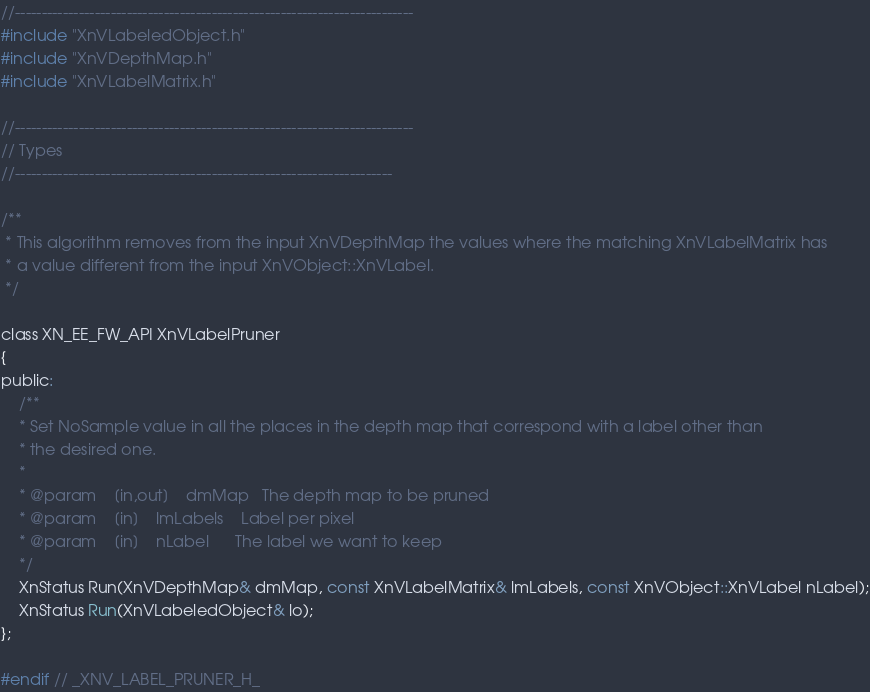Convert code to text. <code><loc_0><loc_0><loc_500><loc_500><_C_>//---------------------------------------------------------------------------
#include "XnVLabeledObject.h"
#include "XnVDepthMap.h"
#include "XnVLabelMatrix.h"

//---------------------------------------------------------------------------
// Types
//-----------------------------------------------------------------------

/**
 * This algorithm removes from the input XnVDepthMap the values where the matching XnVLabelMatrix has 
 * a value different from the input XnVObject::XnVLabel.
 */

class XN_EE_FW_API XnVLabelPruner
{
public:
	/**
	* Set NoSample value in all the places in the depth map that correspond with a label other than
	* the desired one.
	*
	* @param	[in,out]	dmMap	The depth map to be pruned
	* @param	[in]	lmLabels	Label per pixel
	* @param	[in]	nLabel		The label we want to keep
	*/
	XnStatus Run(XnVDepthMap& dmMap, const XnVLabelMatrix& lmLabels, const XnVObject::XnVLabel nLabel);
	XnStatus Run(XnVLabeledObject& lo);
};

#endif // _XNV_LABEL_PRUNER_H_
</code> 